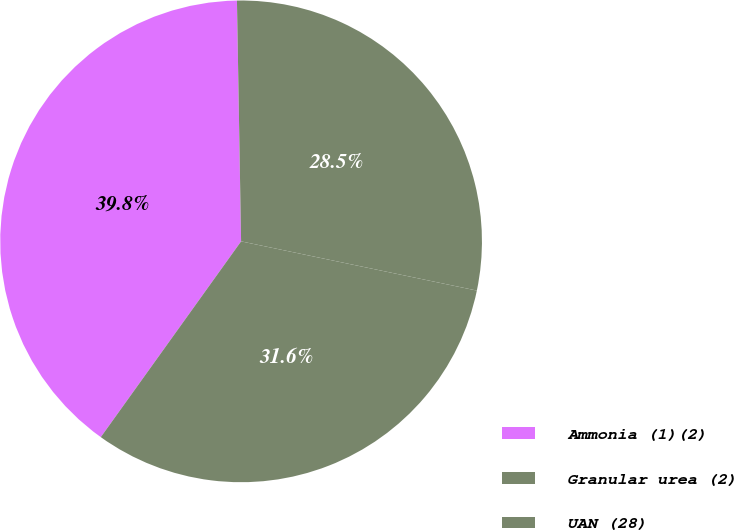Convert chart to OTSL. <chart><loc_0><loc_0><loc_500><loc_500><pie_chart><fcel>Ammonia (1)(2)<fcel>Granular urea (2)<fcel>UAN (28)<nl><fcel>39.83%<fcel>28.55%<fcel>31.62%<nl></chart> 